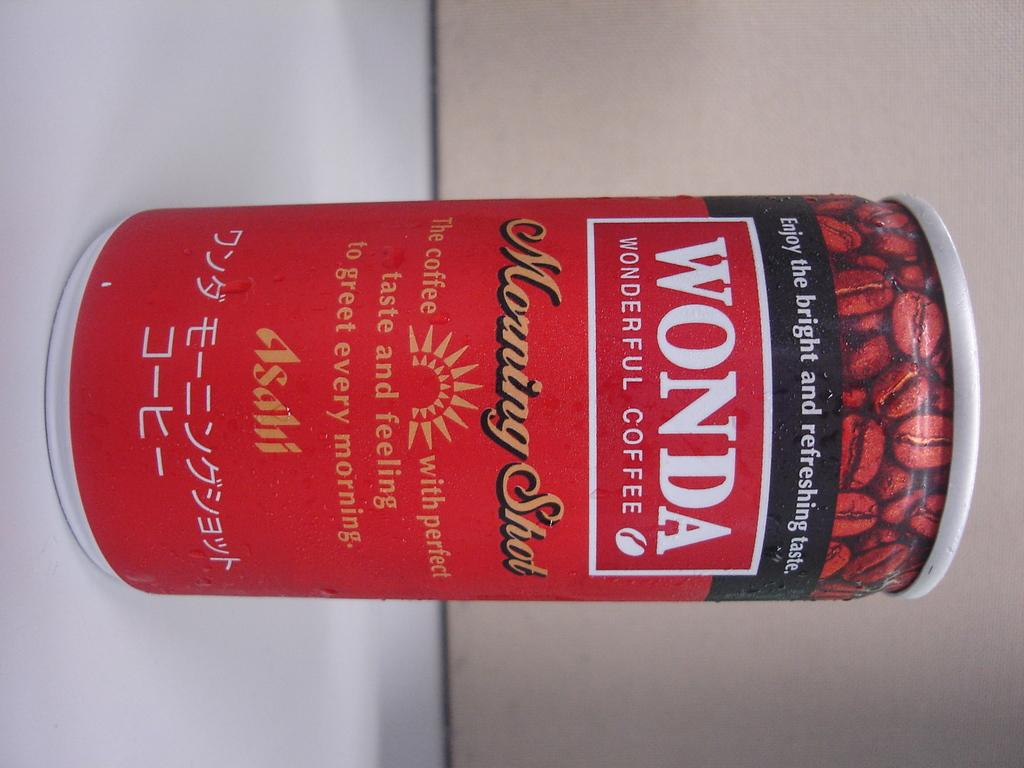<image>
Render a clear and concise summary of the photo. A can of Wonda wonderful Coffee has the logo Enjoy the bright and refreshing taste on it. 